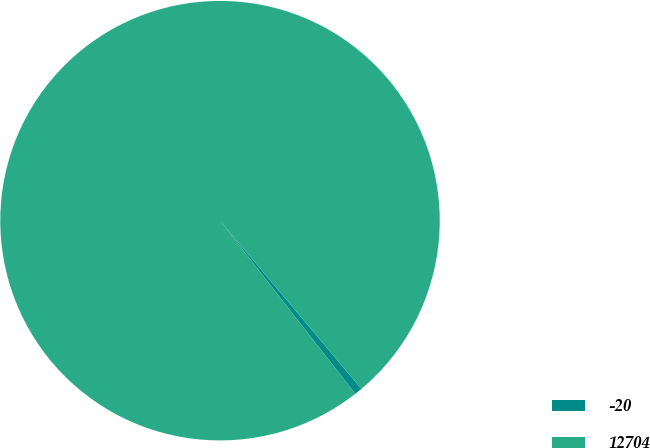Convert chart to OTSL. <chart><loc_0><loc_0><loc_500><loc_500><pie_chart><fcel>-20<fcel>12704<nl><fcel>0.57%<fcel>99.43%<nl></chart> 